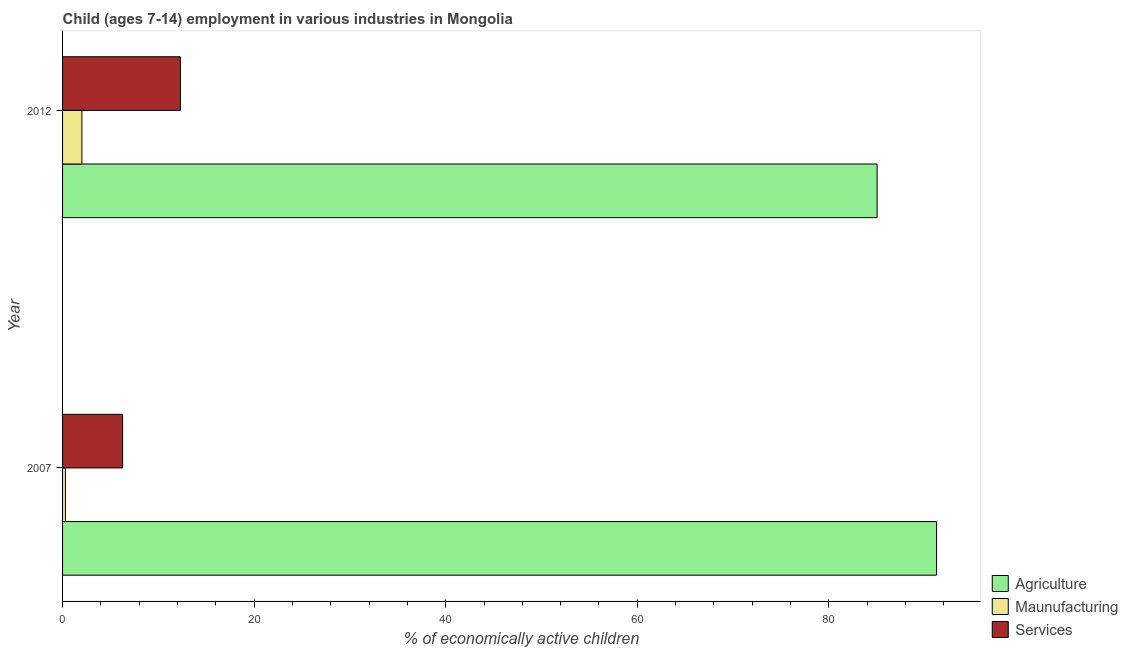How many bars are there on the 1st tick from the top?
Your answer should be very brief. 3. What is the percentage of economically active children in services in 2007?
Offer a very short reply. 6.27. Across all years, what is the maximum percentage of economically active children in services?
Your response must be concise. 12.3. Across all years, what is the minimum percentage of economically active children in services?
Keep it short and to the point. 6.27. In which year was the percentage of economically active children in services minimum?
Give a very brief answer. 2007. What is the total percentage of economically active children in agriculture in the graph?
Provide a succinct answer. 176.29. What is the difference between the percentage of economically active children in agriculture in 2007 and that in 2012?
Your response must be concise. 6.21. What is the average percentage of economically active children in agriculture per year?
Provide a short and direct response. 88.14. In the year 2007, what is the difference between the percentage of economically active children in services and percentage of economically active children in agriculture?
Ensure brevity in your answer.  -84.98. In how many years, is the percentage of economically active children in manufacturing greater than 8 %?
Your response must be concise. 0. What is the ratio of the percentage of economically active children in agriculture in 2007 to that in 2012?
Keep it short and to the point. 1.07. Is the difference between the percentage of economically active children in manufacturing in 2007 and 2012 greater than the difference between the percentage of economically active children in agriculture in 2007 and 2012?
Provide a succinct answer. No. In how many years, is the percentage of economically active children in services greater than the average percentage of economically active children in services taken over all years?
Your answer should be compact. 1. What does the 2nd bar from the top in 2007 represents?
Offer a terse response. Maunufacturing. What does the 2nd bar from the bottom in 2012 represents?
Offer a very short reply. Maunufacturing. What is the difference between two consecutive major ticks on the X-axis?
Provide a succinct answer. 20. Does the graph contain any zero values?
Your answer should be very brief. No. Where does the legend appear in the graph?
Ensure brevity in your answer.  Bottom right. How many legend labels are there?
Your answer should be very brief. 3. How are the legend labels stacked?
Provide a succinct answer. Vertical. What is the title of the graph?
Your answer should be very brief. Child (ages 7-14) employment in various industries in Mongolia. Does "Male employers" appear as one of the legend labels in the graph?
Your answer should be very brief. No. What is the label or title of the X-axis?
Provide a succinct answer. % of economically active children. What is the % of economically active children of Agriculture in 2007?
Your answer should be compact. 91.25. What is the % of economically active children in Maunufacturing in 2007?
Offer a terse response. 0.3. What is the % of economically active children in Services in 2007?
Make the answer very short. 6.27. What is the % of economically active children of Agriculture in 2012?
Offer a very short reply. 85.04. What is the % of economically active children of Maunufacturing in 2012?
Give a very brief answer. 2.02. What is the % of economically active children of Services in 2012?
Offer a very short reply. 12.3. Across all years, what is the maximum % of economically active children in Agriculture?
Your answer should be very brief. 91.25. Across all years, what is the maximum % of economically active children of Maunufacturing?
Offer a terse response. 2.02. Across all years, what is the minimum % of economically active children in Agriculture?
Provide a short and direct response. 85.04. Across all years, what is the minimum % of economically active children of Services?
Make the answer very short. 6.27. What is the total % of economically active children of Agriculture in the graph?
Ensure brevity in your answer.  176.29. What is the total % of economically active children in Maunufacturing in the graph?
Your answer should be compact. 2.32. What is the total % of economically active children in Services in the graph?
Ensure brevity in your answer.  18.57. What is the difference between the % of economically active children in Agriculture in 2007 and that in 2012?
Your answer should be very brief. 6.21. What is the difference between the % of economically active children in Maunufacturing in 2007 and that in 2012?
Your answer should be very brief. -1.72. What is the difference between the % of economically active children in Services in 2007 and that in 2012?
Your answer should be compact. -6.03. What is the difference between the % of economically active children of Agriculture in 2007 and the % of economically active children of Maunufacturing in 2012?
Keep it short and to the point. 89.23. What is the difference between the % of economically active children of Agriculture in 2007 and the % of economically active children of Services in 2012?
Your answer should be very brief. 78.95. What is the difference between the % of economically active children in Maunufacturing in 2007 and the % of economically active children in Services in 2012?
Provide a succinct answer. -12. What is the average % of economically active children of Agriculture per year?
Make the answer very short. 88.14. What is the average % of economically active children in Maunufacturing per year?
Ensure brevity in your answer.  1.16. What is the average % of economically active children of Services per year?
Keep it short and to the point. 9.29. In the year 2007, what is the difference between the % of economically active children in Agriculture and % of economically active children in Maunufacturing?
Provide a short and direct response. 90.95. In the year 2007, what is the difference between the % of economically active children in Agriculture and % of economically active children in Services?
Give a very brief answer. 84.98. In the year 2007, what is the difference between the % of economically active children in Maunufacturing and % of economically active children in Services?
Provide a succinct answer. -5.97. In the year 2012, what is the difference between the % of economically active children in Agriculture and % of economically active children in Maunufacturing?
Make the answer very short. 83.02. In the year 2012, what is the difference between the % of economically active children in Agriculture and % of economically active children in Services?
Make the answer very short. 72.74. In the year 2012, what is the difference between the % of economically active children of Maunufacturing and % of economically active children of Services?
Ensure brevity in your answer.  -10.28. What is the ratio of the % of economically active children of Agriculture in 2007 to that in 2012?
Provide a succinct answer. 1.07. What is the ratio of the % of economically active children of Maunufacturing in 2007 to that in 2012?
Provide a succinct answer. 0.15. What is the ratio of the % of economically active children in Services in 2007 to that in 2012?
Your answer should be very brief. 0.51. What is the difference between the highest and the second highest % of economically active children of Agriculture?
Make the answer very short. 6.21. What is the difference between the highest and the second highest % of economically active children in Maunufacturing?
Ensure brevity in your answer.  1.72. What is the difference between the highest and the second highest % of economically active children of Services?
Offer a very short reply. 6.03. What is the difference between the highest and the lowest % of economically active children of Agriculture?
Ensure brevity in your answer.  6.21. What is the difference between the highest and the lowest % of economically active children of Maunufacturing?
Your answer should be compact. 1.72. What is the difference between the highest and the lowest % of economically active children in Services?
Give a very brief answer. 6.03. 